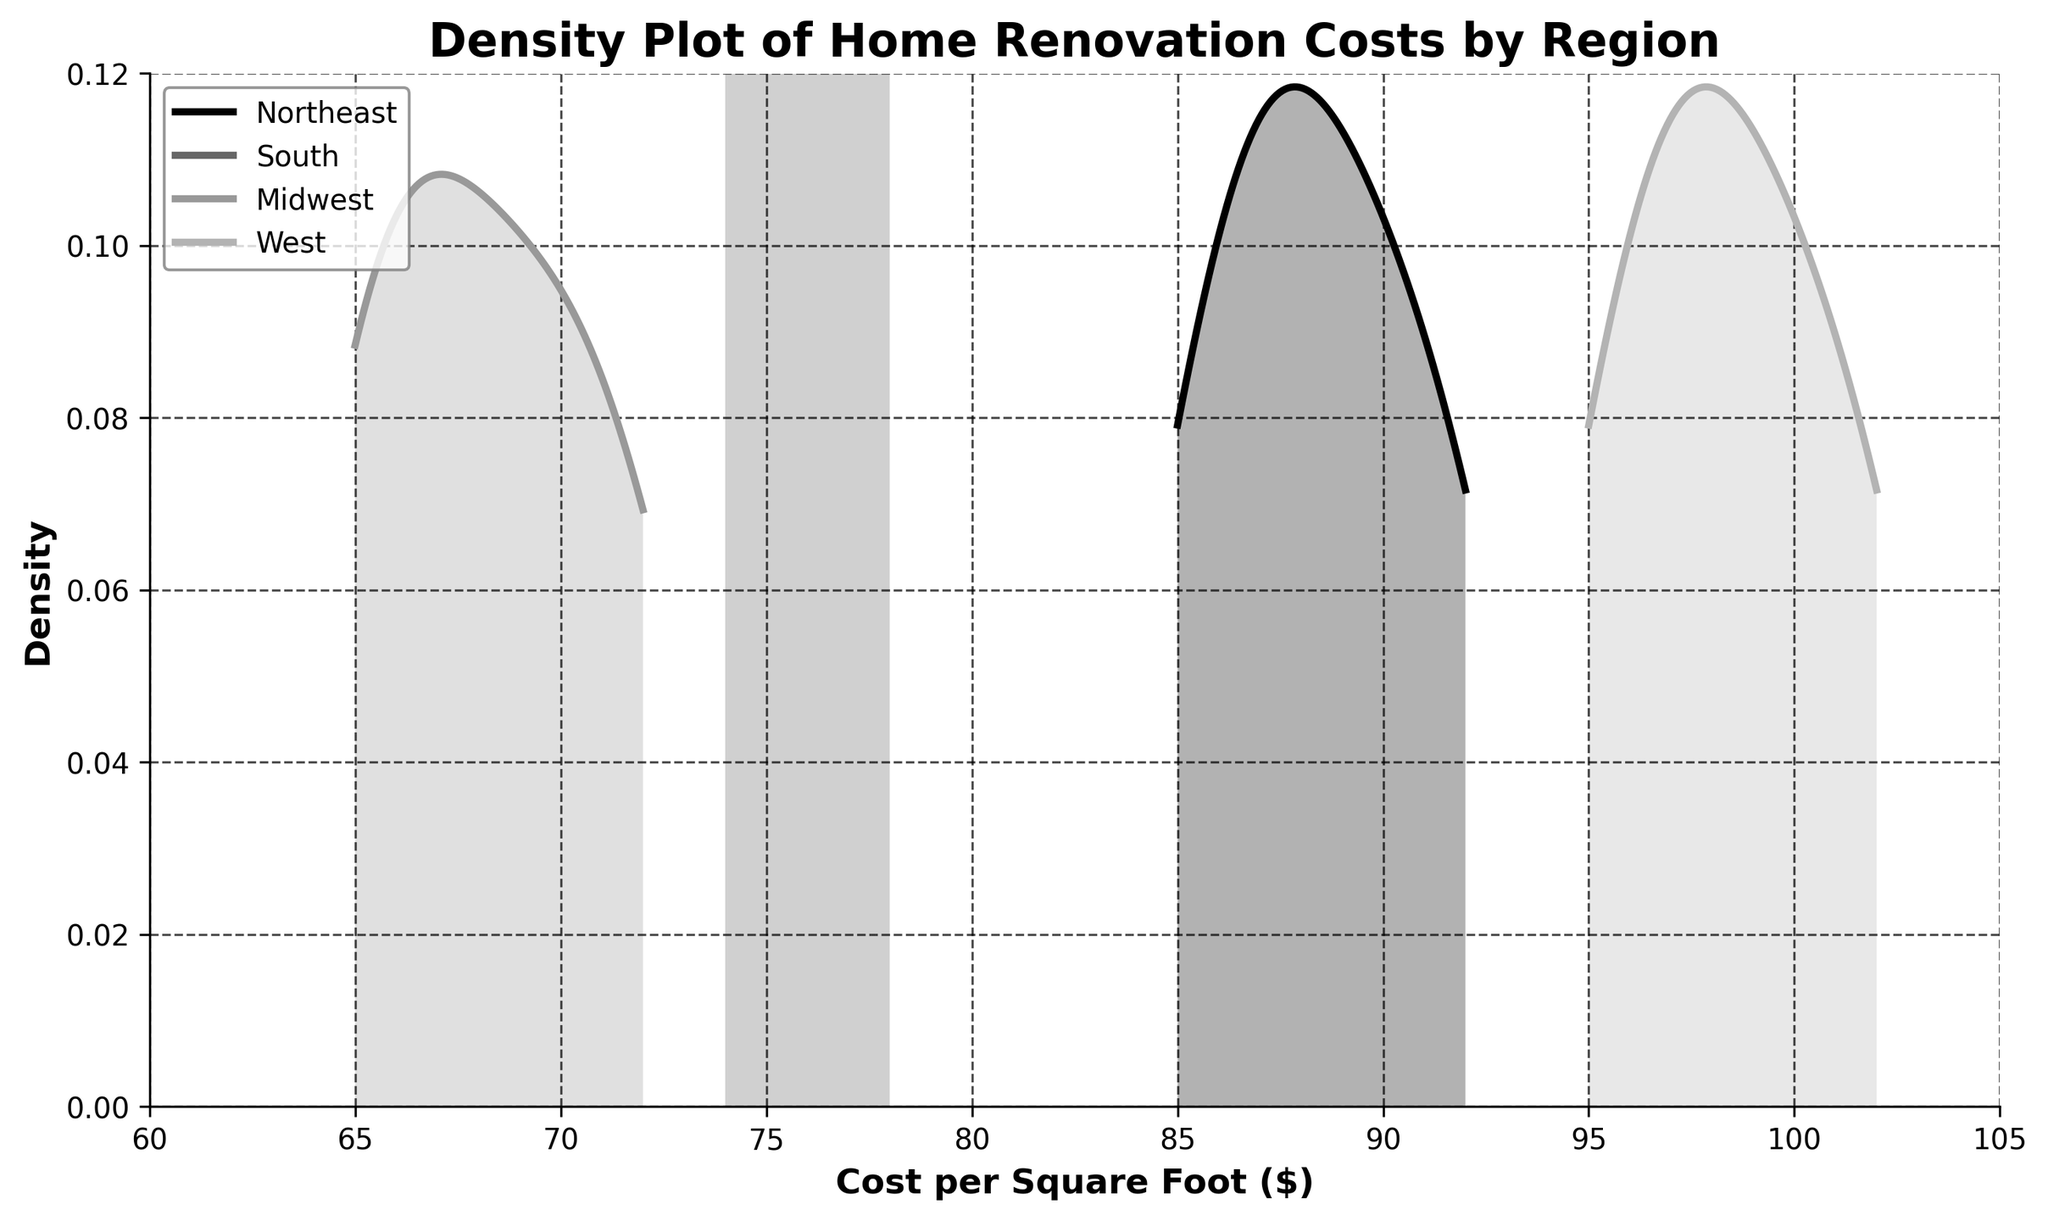What's the title of the figure? The title of the figure is written at the top and should be directly readable. It usually summarizes the main insight of the plot.
Answer: Density Plot of Home Renovation Costs by Region What does the y-axis represent? The y-axis typically indicates the density, a measure of how common different cost values per square foot are within each region.
Answer: Density How many different regions are compared in the plot? There are four distinct lines, each labeled with a region name in the legend, representing the four regions.
Answer: 4 Which region has the highest cost per square foot density peak? By inspecting the plot, the region with the highest peak on the y-axis is the one with the densest distribution.
Answer: West What is the approximate range of costs per square foot for the Northeast region? By observing the endpoints of the line corresponding to the Northeast region, we can estimate the range of costs per square foot.
Answer: 85-92 Which region shows the greatest variability in cost per square foot? The spread of the density curve indicates variability. The region with the flattest and widest curve shows the highest variability.
Answer: Midwest Between which two regions is the cost per square foot most similar in terms of density shapes? To determine similarity, we compare the shapes and positions of the density curves for all regions.
Answer: Northeast and South What is the difference in the cost per square foot between the highest and lowest density peaks? Identify the cost values at the peaks and subtract the lowest from the highest to get the difference.
Answer: 102 - 65 = 37 Do any regions have overlapping cost per square foot ranges? Overlapping curves in the density plot indicate regions with similar cost per square foot ranges.
Answer: Yes Which region has the lowest variability in cost per square foot? The region with the narrowest and highest density peak indicates the least variability.
Answer: West 